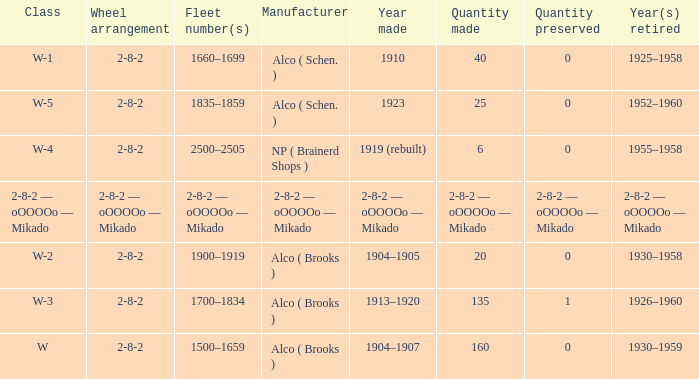What is the locomotive class that has a wheel arrangement of 2-8-2 and a quantity made of 25? W-5. 